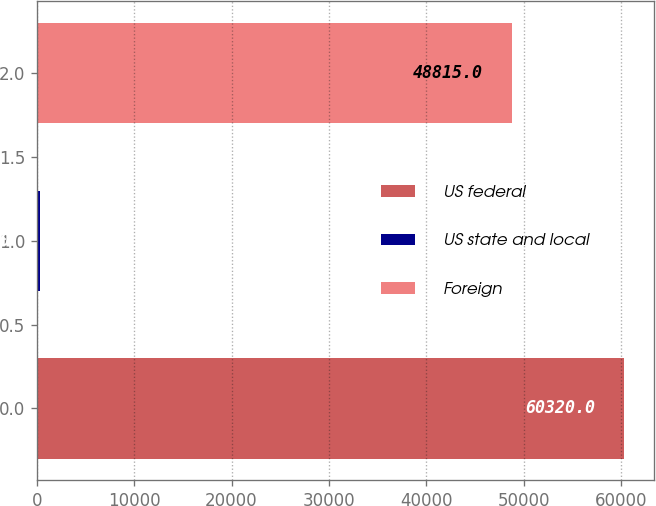Convert chart. <chart><loc_0><loc_0><loc_500><loc_500><bar_chart><fcel>US federal<fcel>US state and local<fcel>Foreign<nl><fcel>60320<fcel>331<fcel>48815<nl></chart> 